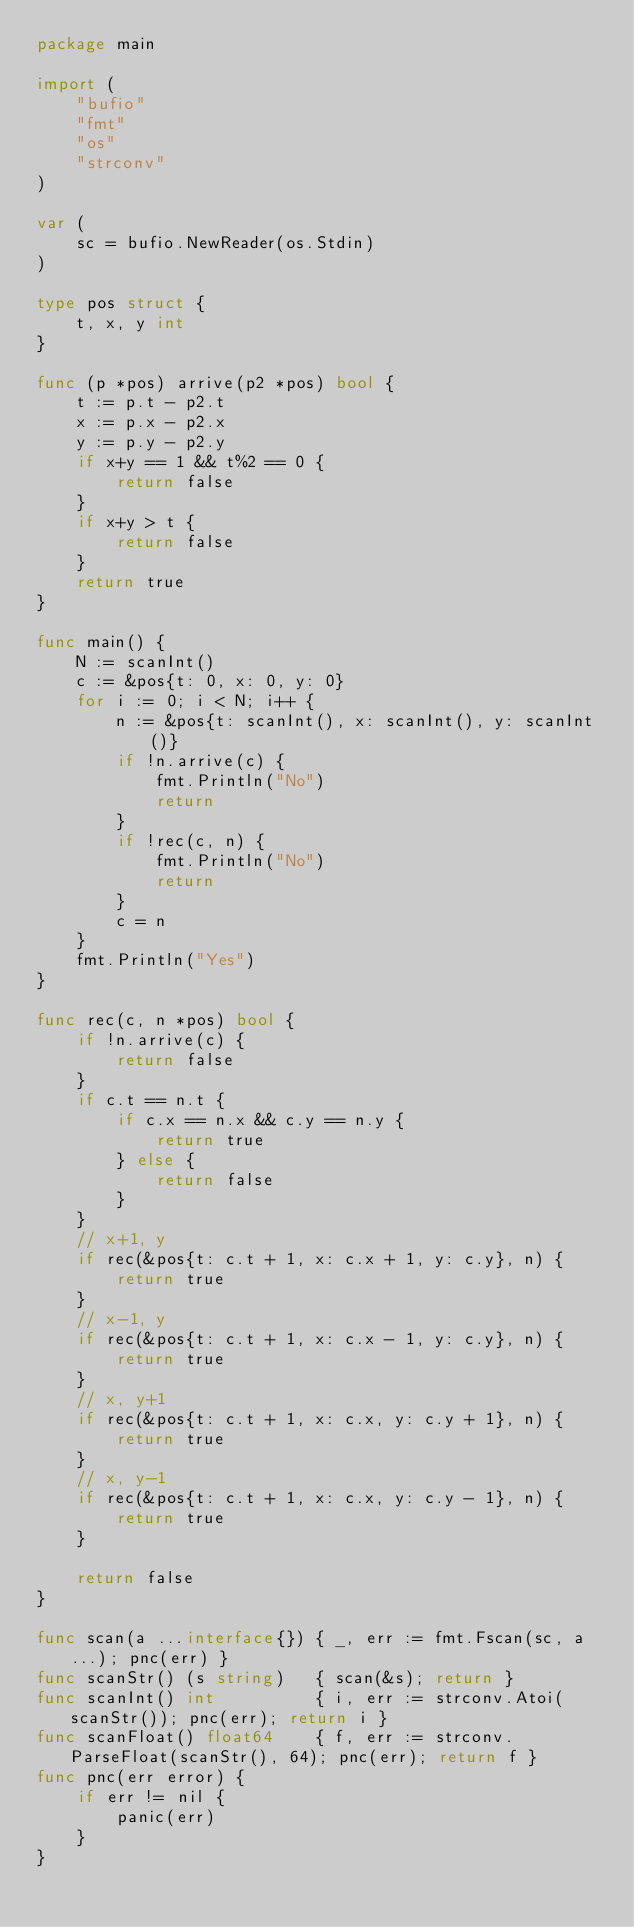<code> <loc_0><loc_0><loc_500><loc_500><_Go_>package main

import (
	"bufio"
	"fmt"
	"os"
	"strconv"
)

var (
	sc = bufio.NewReader(os.Stdin)
)

type pos struct {
	t, x, y int
}

func (p *pos) arrive(p2 *pos) bool {
	t := p.t - p2.t
	x := p.x - p2.x
	y := p.y - p2.y
	if x+y == 1 && t%2 == 0 {
		return false
	}
	if x+y > t {
		return false
	}
	return true
}

func main() {
	N := scanInt()
	c := &pos{t: 0, x: 0, y: 0}
	for i := 0; i < N; i++ {
		n := &pos{t: scanInt(), x: scanInt(), y: scanInt()}
		if !n.arrive(c) {
			fmt.Println("No")
			return
		}
		if !rec(c, n) {
			fmt.Println("No")
			return
		}
		c = n
	}
	fmt.Println("Yes")
}

func rec(c, n *pos) bool {
	if !n.arrive(c) {
		return false
	}
	if c.t == n.t {
		if c.x == n.x && c.y == n.y {
			return true
		} else {
			return false
		}
	}
	// x+1, y
	if rec(&pos{t: c.t + 1, x: c.x + 1, y: c.y}, n) {
		return true
	}
	// x-1, y
	if rec(&pos{t: c.t + 1, x: c.x - 1, y: c.y}, n) {
		return true
	}
	// x, y+1
	if rec(&pos{t: c.t + 1, x: c.x, y: c.y + 1}, n) {
		return true
	}
	// x, y-1
	if rec(&pos{t: c.t + 1, x: c.x, y: c.y - 1}, n) {
		return true
	}

	return false
}

func scan(a ...interface{}) { _, err := fmt.Fscan(sc, a...); pnc(err) }
func scanStr() (s string)   { scan(&s); return }
func scanInt() int          { i, err := strconv.Atoi(scanStr()); pnc(err); return i }
func scanFloat() float64    { f, err := strconv.ParseFloat(scanStr(), 64); pnc(err); return f }
func pnc(err error) {
	if err != nil {
		panic(err)
	}
}
</code> 